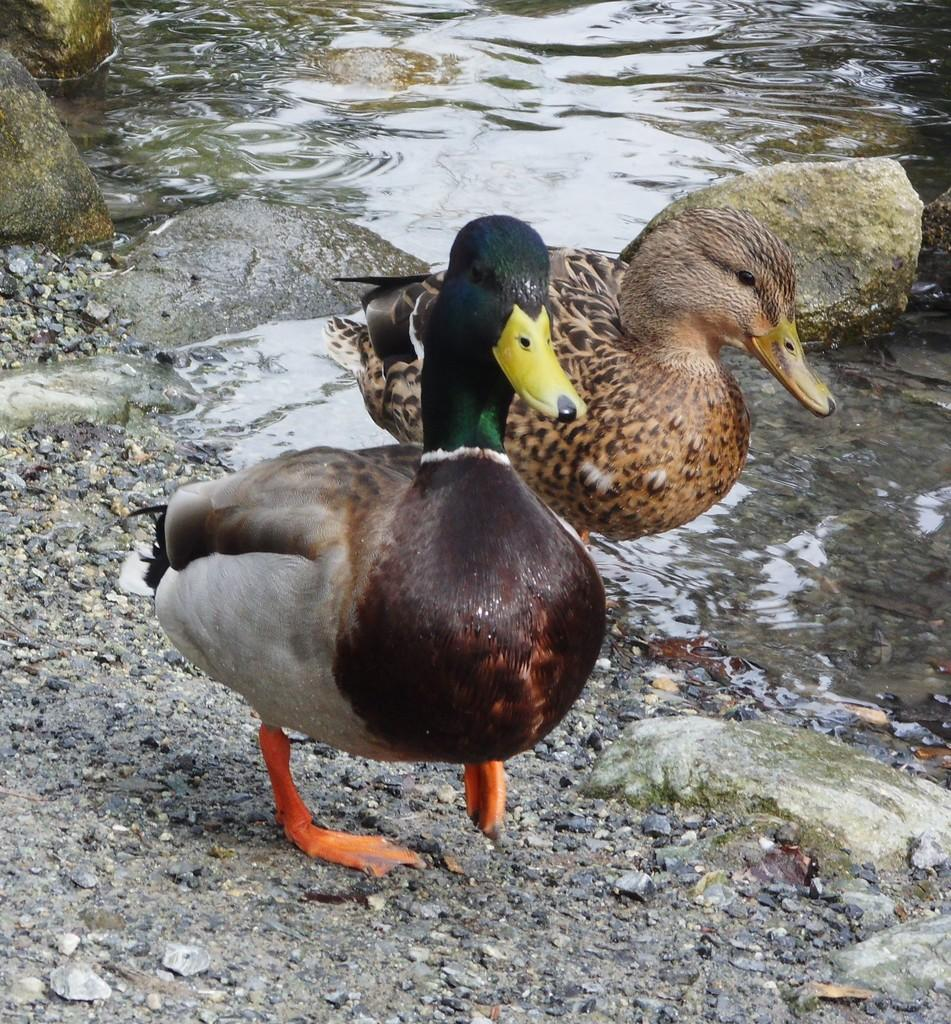What type of animals are present in the image? There are ducks in the image. What other objects can be seen in the image? There are stones and rocks visible in the image. What is the primary element in the image? There is water visible in the image. Can you describe the action of one of the ducks in the image? A duck is walking on the surface of the water. What type of bulb can be seen lighting up the train in the image? There is no train or bulb present in the image; it features ducks, stones, rocks, and water. 